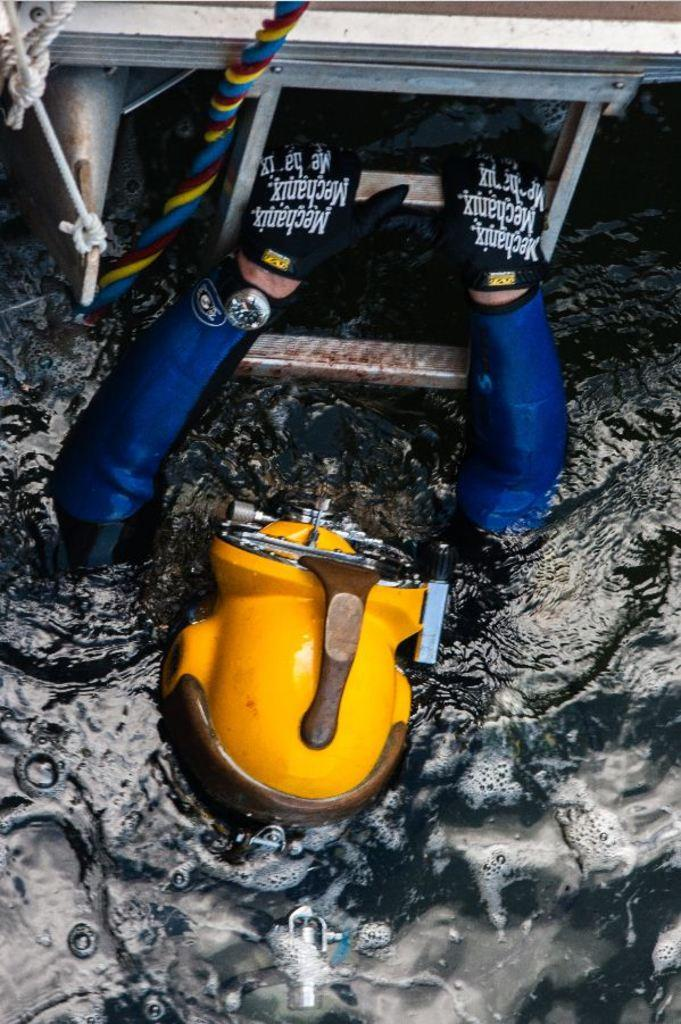Who is the main subject in the foreground of the image? There is a man in the foreground of the image. What is the man wearing on his hands? The man is wearing gloves. What is the man wearing on his head? The man is wearing a helmet. What is attached to the man's back? The man has a cylinder on his back. What is the man's location in the image? The man is in the water. What is the man holding in the image? The man is holding the ladder of a water vehicle. How does the man cry for help in the image? The man is not shown crying for help in the image; he is holding the ladder of a water vehicle. Is there any snow visible in the image? No, there is no snow present in the image; the man is in the water. 